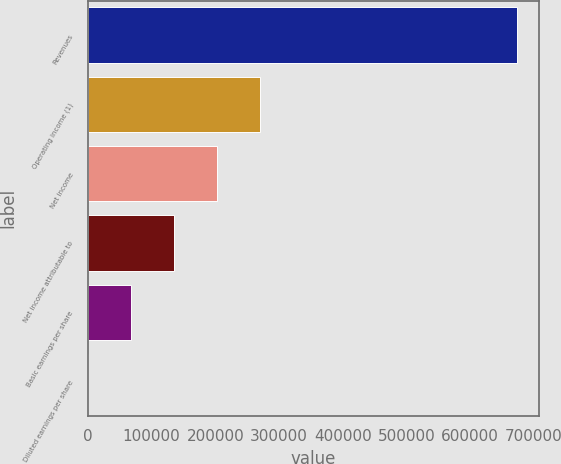Convert chart to OTSL. <chart><loc_0><loc_0><loc_500><loc_500><bar_chart><fcel>Revenues<fcel>Operating income (1)<fcel>Net income<fcel>Net income attributable to<fcel>Basic earnings per share<fcel>Diluted earnings per share<nl><fcel>673977<fcel>269591<fcel>202194<fcel>134796<fcel>67398.4<fcel>0.72<nl></chart> 